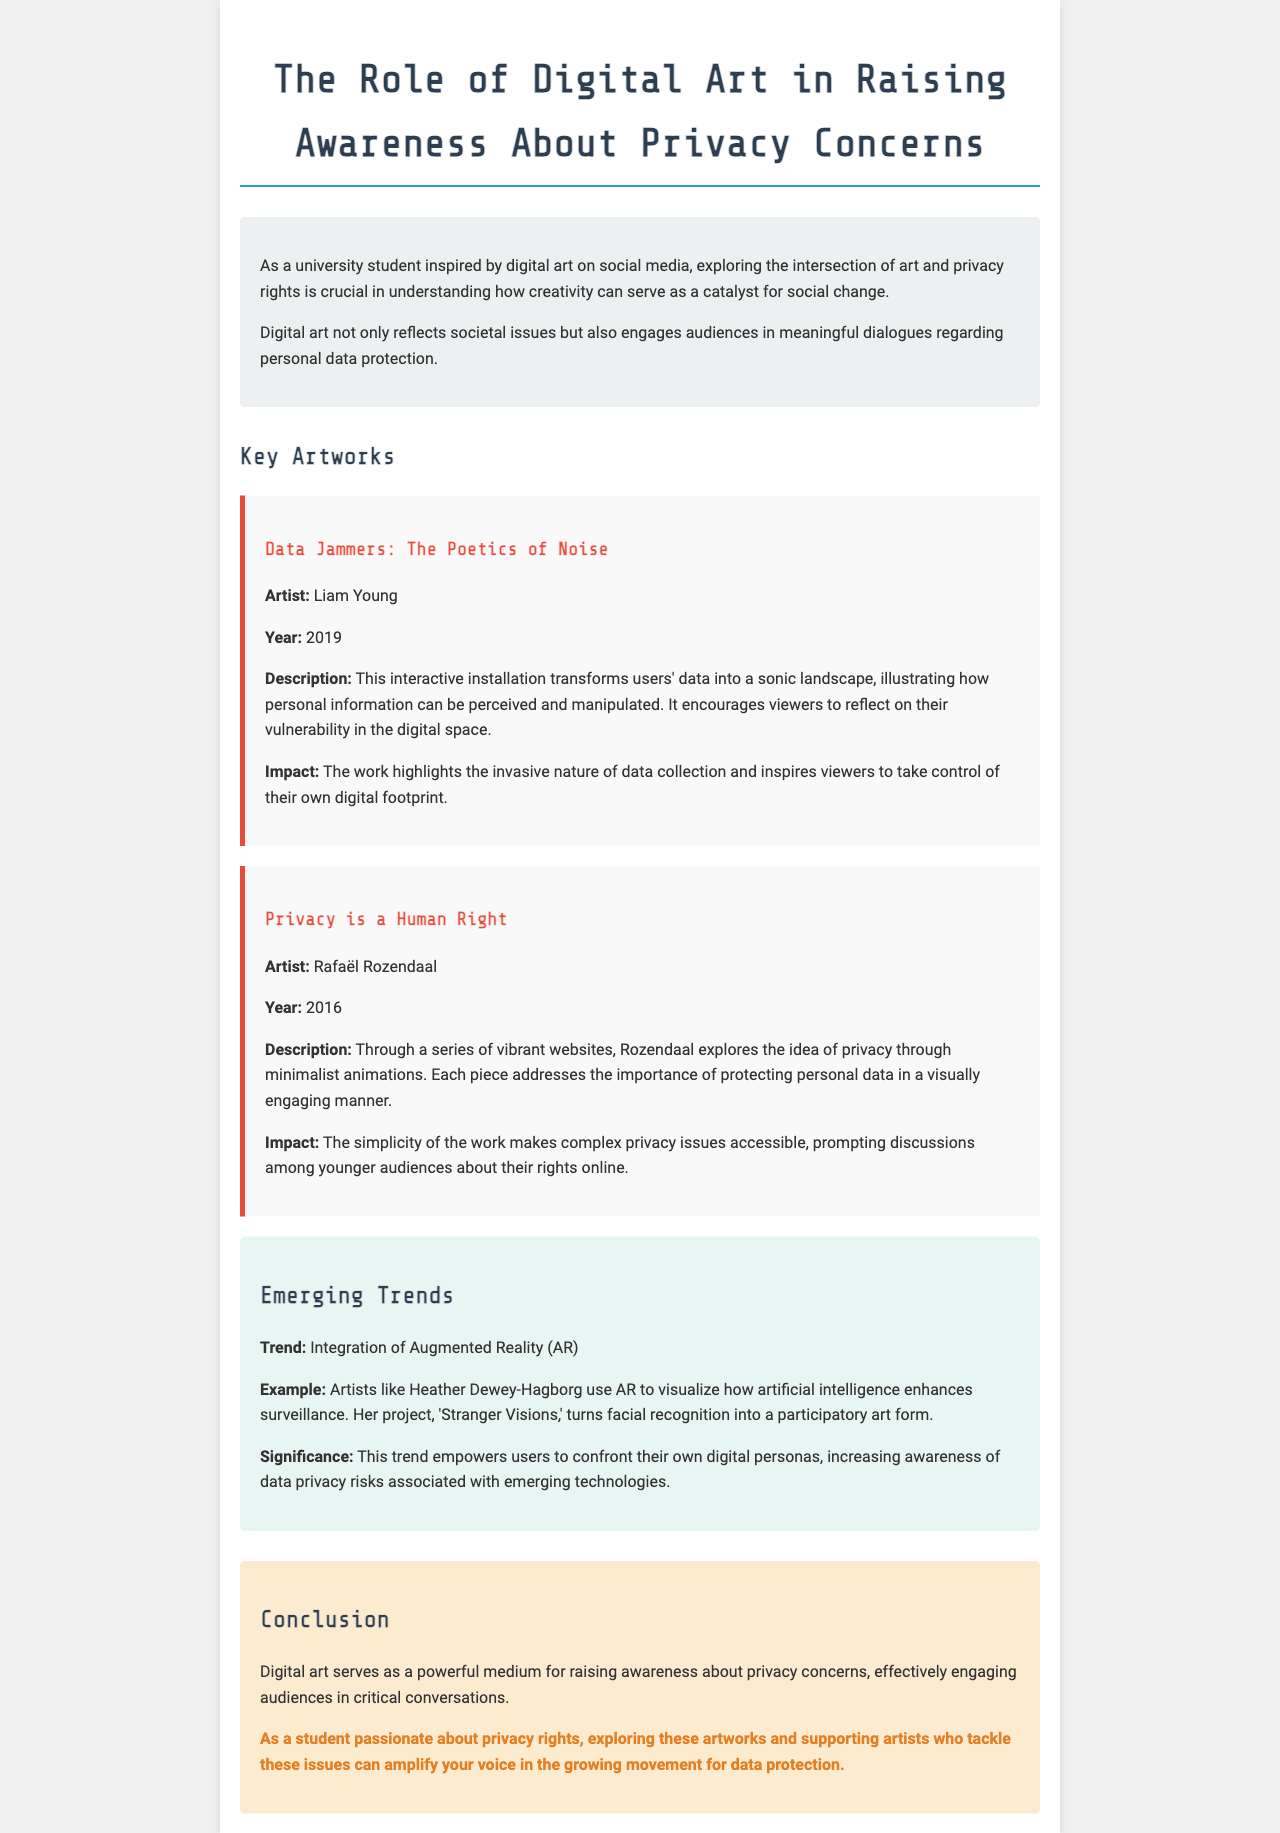What is the title of the report? The title of the report is mentioned at the top of the document.
Answer: The Role of Digital Art in Raising Awareness About Privacy Concerns Who is the artist behind "Data Jammers: The Poetics of Noise"? The artist is credited in the section discussing the specific artwork.
Answer: Liam Young In what year was "Privacy is a Human Right" created? The year of creation is provided in the description of that artwork.
Answer: 2016 What is a significant trend mentioned in the report? The report discusses an emerging trend related to technology in the arts.
Answer: Integration of Augmented Reality (AR) What is the main purpose of the artworks discussed in the report? The report outlines the overall intention behind these digital artworks.
Answer: Raising awareness about privacy concerns What does "Stranger Visions" visualize? The project is briefly described, focusing on its thematic elements.
Answer: Facial recognition What color is used to highlight the artworks section in the document? The background color of the section helps identify it visually.
Answer: Red What does the call-to-action encourage readers to do? The call-to-action outlines a specific action for students passionate about privacy rights.
Answer: Explore these artworks and support artists 